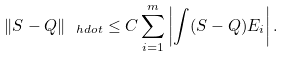<formula> <loc_0><loc_0><loc_500><loc_500>\| S - Q \| _ { \ h d o t } \leq C \sum _ { i = 1 } ^ { m } \left | \int ( S - Q ) E _ { i } \right | .</formula> 